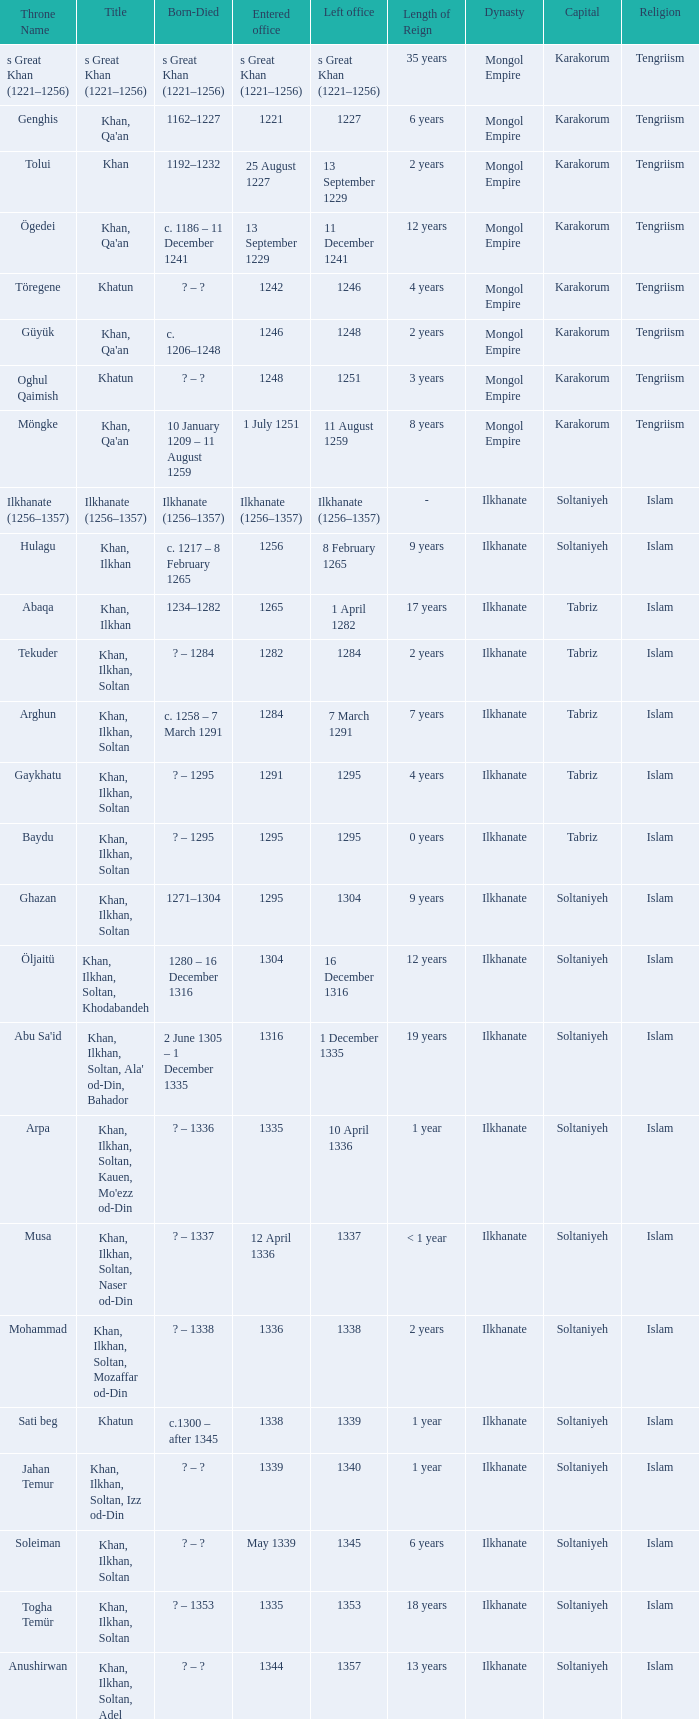What is the entered office that has 1337 as the left office? 12 April 1336. 